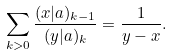Convert formula to latex. <formula><loc_0><loc_0><loc_500><loc_500>\sum _ { k > 0 } \frac { ( x | a ) _ { k - 1 } } { ( y | a ) _ { k } } = \frac { 1 } { y - x } .</formula> 